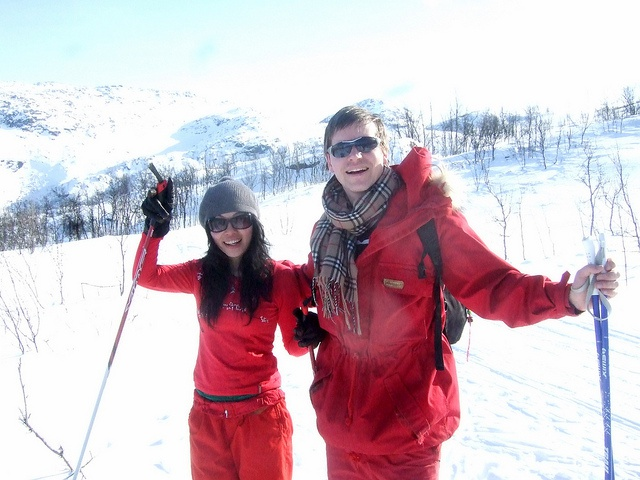Describe the objects in this image and their specific colors. I can see people in lightblue, brown, maroon, and gray tones, people in lightblue, brown, black, and maroon tones, and backpack in lightblue, black, gray, and purple tones in this image. 